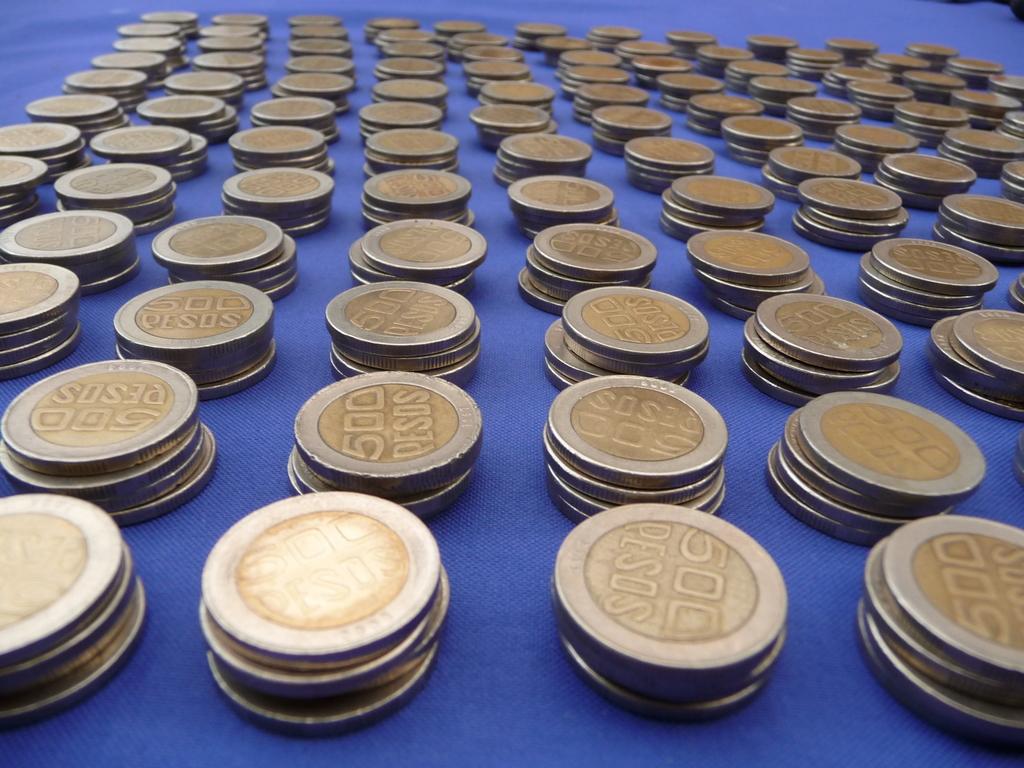What currency are these coins?
Offer a very short reply. Pesos. How many pesos is each coin worth?
Your answer should be compact. 500. 